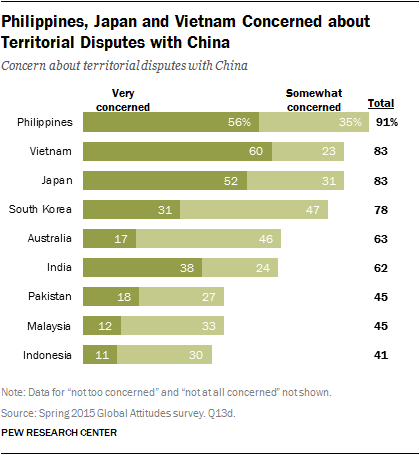Draw attention to some important aspects in this diagram. A recent survey in Japan has revealed that a significant percentage of the population, 31%, is somewhat concerned about territorial disputes with China. According to a survey conducted in the Philippines, a majority of people are very concerned about territorial disputes with China, with a percentage of 0.56. 